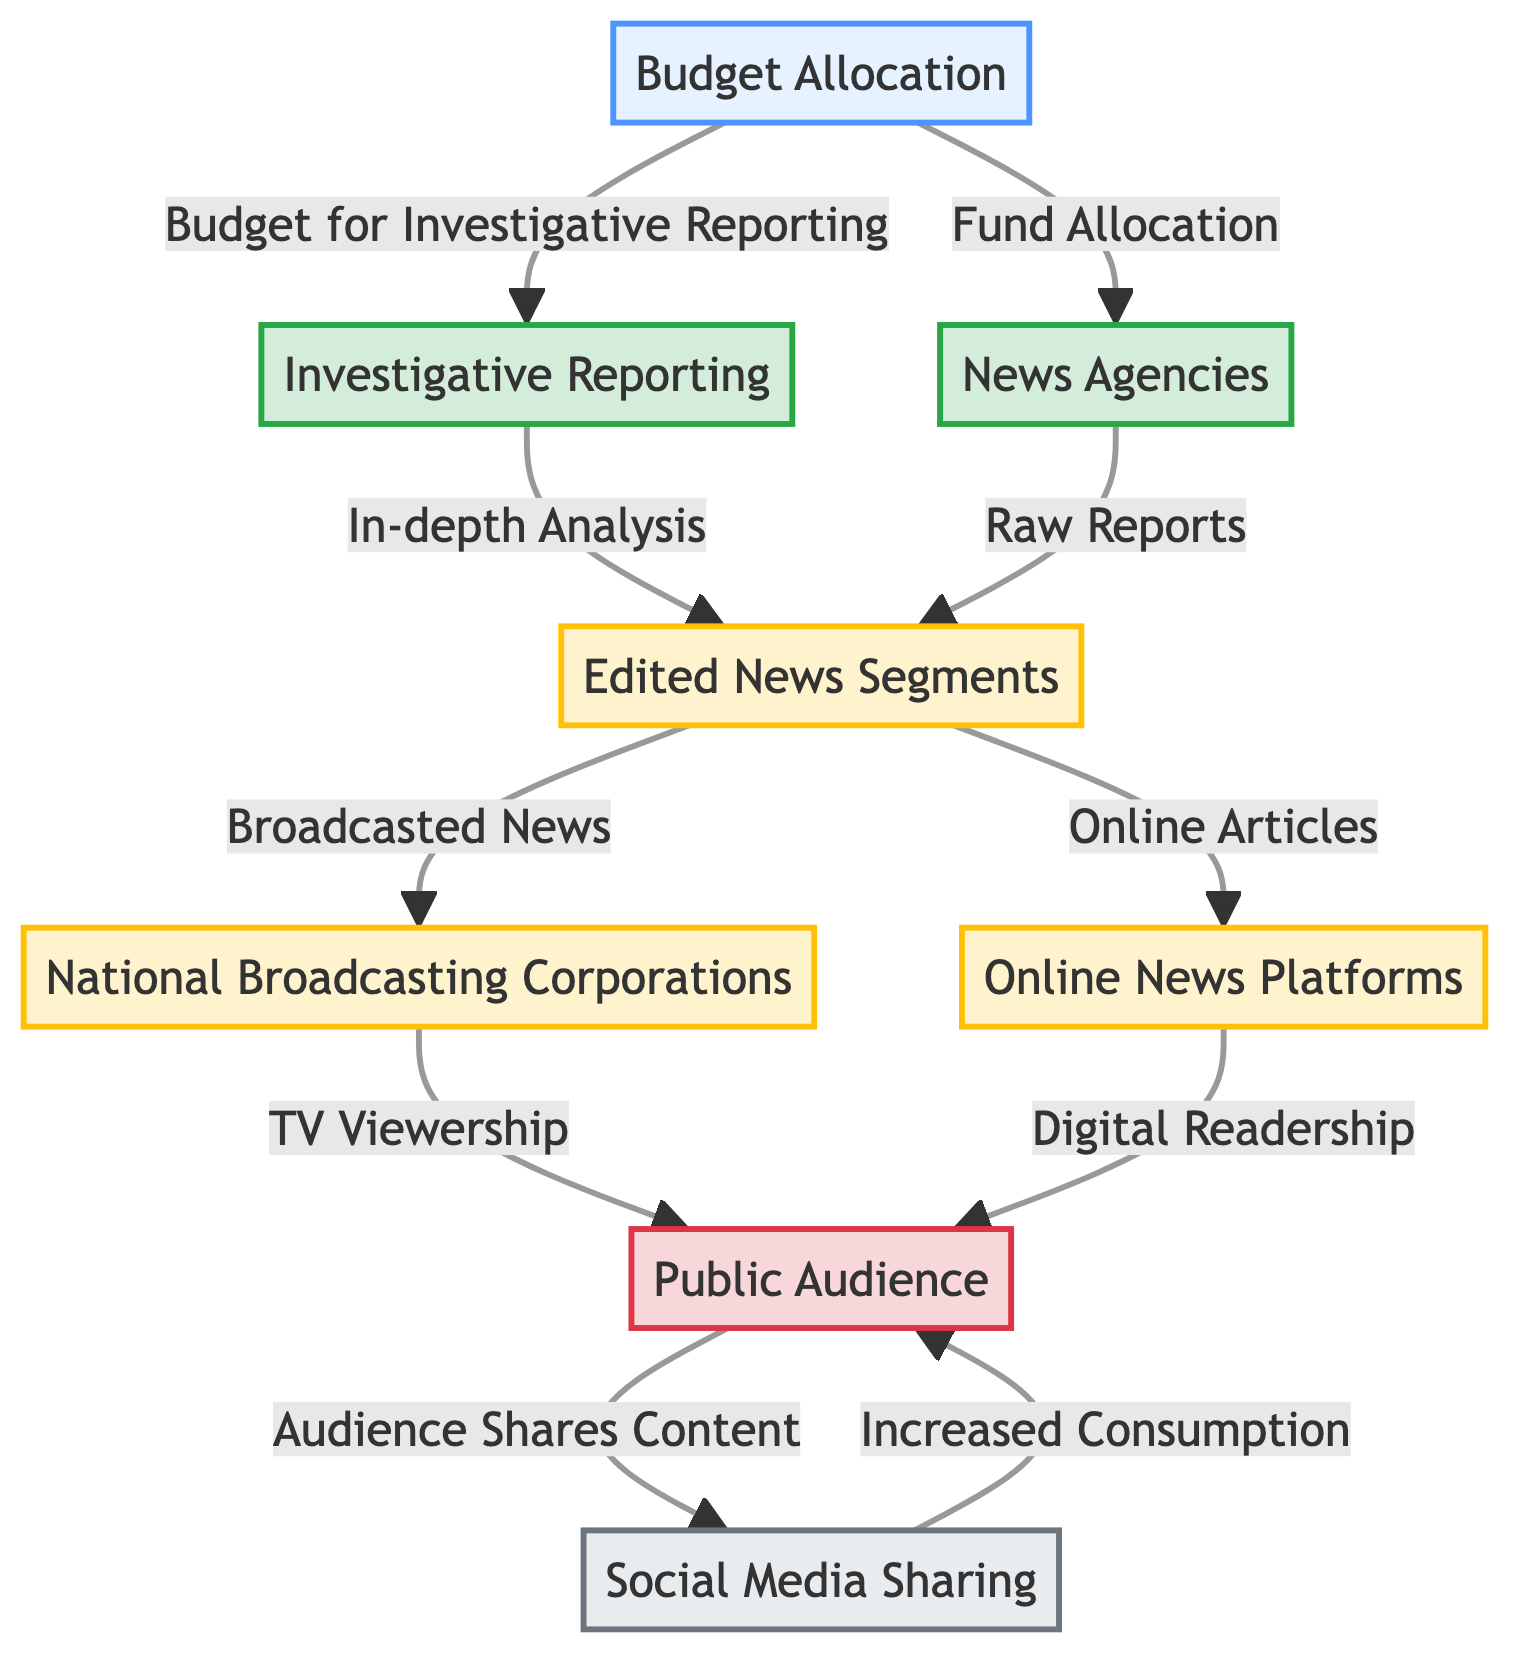What is the primary source of budget allocation in the diagram? The diagram indicates that "Budget Allocation" is the main starting node, from which funds are directed towards "Investigative Reporting" and "News Agencies".
Answer: Budget Allocation How many secondary producers are identified in the diagram? The secondary producers represented in the diagram include "Edited News Segments", "National Broadcasting Corporations", and "Online News Platforms", totaling three distinct nodes in that category.
Answer: 3 Which node receives raw reports from news agencies? The diagram shows that "Raw Reports" are directed to the node "Edited News Segments", making it the recipient of raw outputs from news agencies.
Answer: Edited News Segments What is implicit in the flow from the public audience to social media sharing? The diagram implies that the public audience engages with content, leading to "Audience Shares Content", which signifies the interaction between audience consumption and amplification of that content through social media.
Answer: Audience Shares Content What links investigative reporting to edited news segments? The connection is represented by the relationship "In-depth Analysis", indicating that the outputs of investigative reporting contribute detailed insights that are organized into edited news segments.
Answer: In-depth Analysis Which components constitute the primary producers in the model? The primary producers defined in the flowchart are "Investigative Reporting" and "News Agencies", outlining the initial sources of journalistic content before it is edited or broadcasted.
Answer: Investigative Reporting, News Agencies What is the result of the audience sharing content on social media? The diagram indicates that the action of the audience sharing content leads to "Increased Consumption", demonstrating the feedback loop between audience behavior and content consumption.
Answer: Increased Consumption How does edited news segments reach the public audience? According to the diagram, "Edited News Segments" distribute their outputs as "Broadcasted News" to "National Broadcasting Corporations" and "Online Articles" to "Online News Platforms", both of which contribute to reaching the public audience.
Answer: Broadcasted News, Online Articles What direction does the flow of budget allocation initially take? The budget allocation originates from "Budget Allocation" and can move towards two primary nodes: "Investigative Reporting" and "News Agencies", indicating an initial bifurcation in resource direction.
Answer: Investigative Reporting, News Agencies 